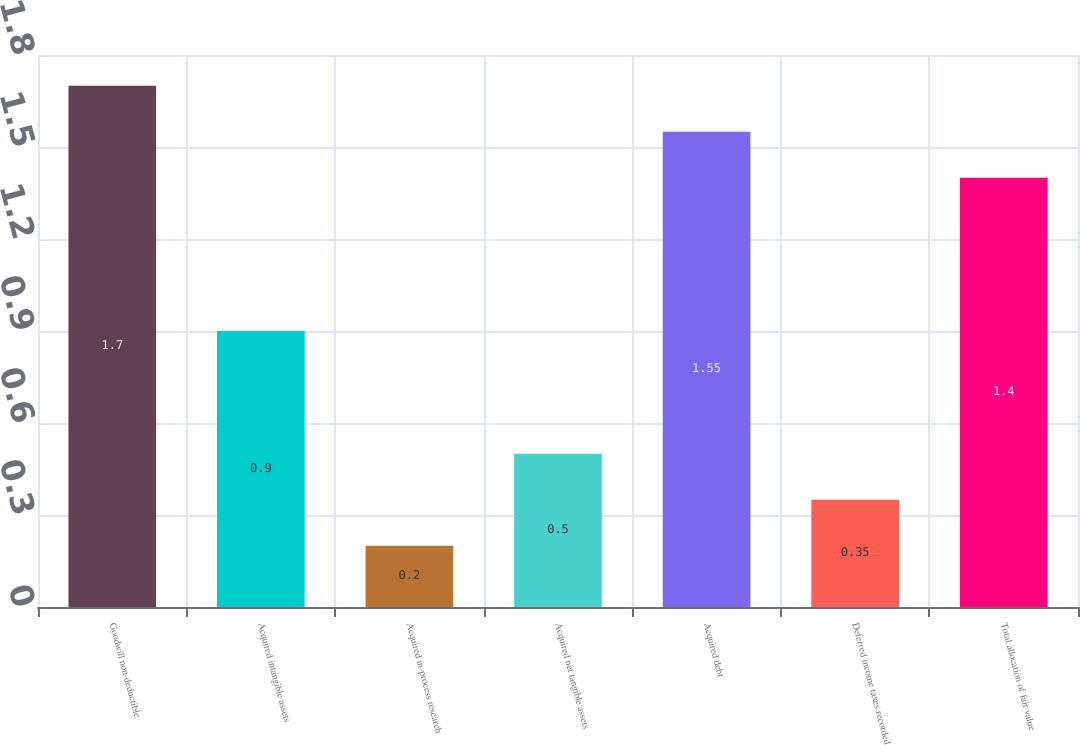Convert chart. <chart><loc_0><loc_0><loc_500><loc_500><bar_chart><fcel>Goodwill non-deductible<fcel>Acquired intangible assets<fcel>Acquired in-process research<fcel>Acquired net tangible assets<fcel>Acquired debt<fcel>Deferred income taxes recorded<fcel>Total allocation of fair value<nl><fcel>1.7<fcel>0.9<fcel>0.2<fcel>0.5<fcel>1.55<fcel>0.35<fcel>1.4<nl></chart> 